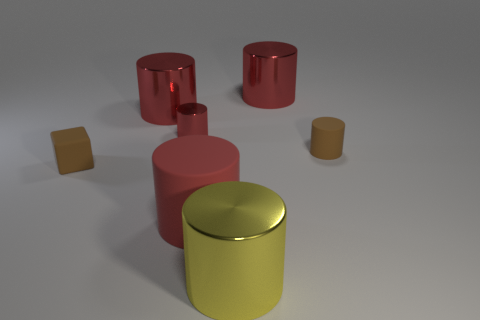There is a tiny metallic thing that is the same color as the big matte thing; what is its shape?
Your response must be concise. Cylinder. Do the small cube and the tiny rubber cylinder have the same color?
Offer a very short reply. Yes. There is a cylinder that is the same color as the block; what size is it?
Offer a terse response. Small. The large cylinder that is made of the same material as the tiny block is what color?
Provide a short and direct response. Red. There is a yellow shiny object; is its size the same as the rubber cylinder to the right of the yellow metallic cylinder?
Keep it short and to the point. No. There is a small cylinder that is on the left side of the object behind the large shiny cylinder to the left of the big yellow object; what is its material?
Provide a short and direct response. Metal. What number of objects are red metallic cylinders or big red shiny cylinders?
Give a very brief answer. 3. There is a large shiny cylinder that is to the left of the small red cylinder; is its color the same as the tiny cylinder that is to the left of the large red rubber thing?
Ensure brevity in your answer.  Yes. What shape is the metallic object that is the same size as the brown cylinder?
Make the answer very short. Cylinder. What number of things are big cylinders on the left side of the tiny red object or small things to the left of the tiny red object?
Offer a terse response. 2. 